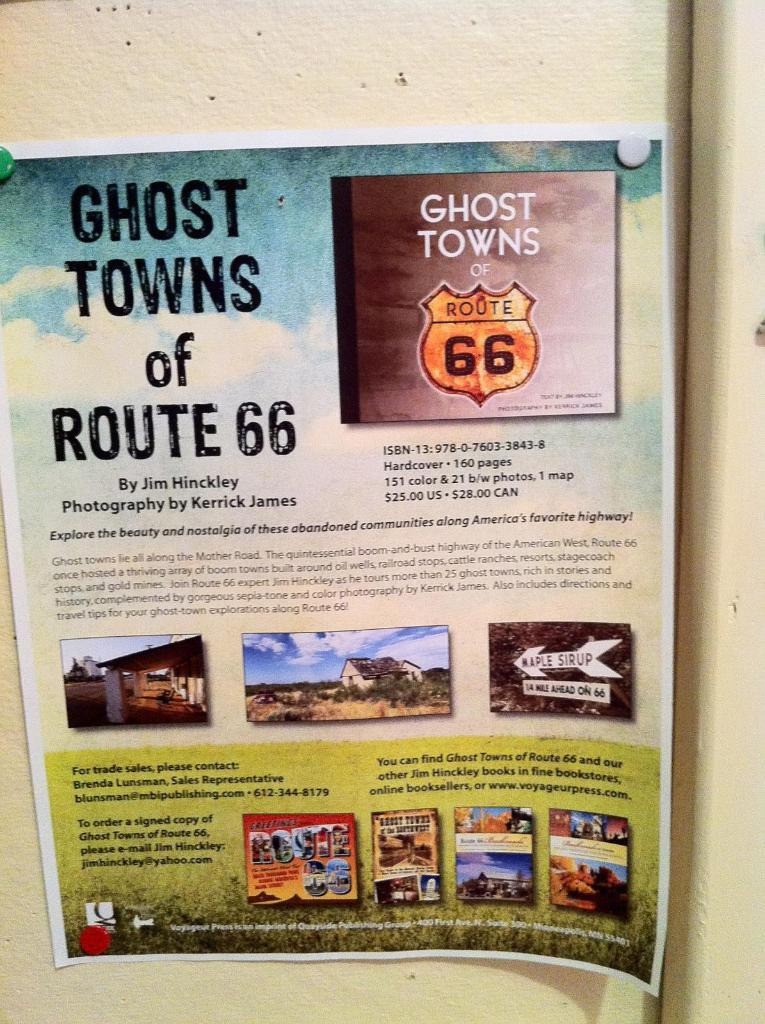<image>
Describe the image concisely. Poster on a wall that says "Ghost Towns of Route 66". 